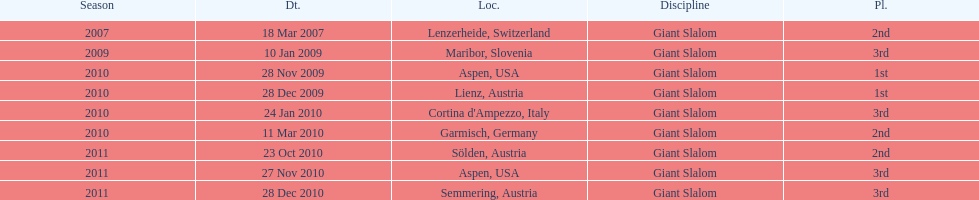What was the finishing place of the last race in december 2010? 3rd. 